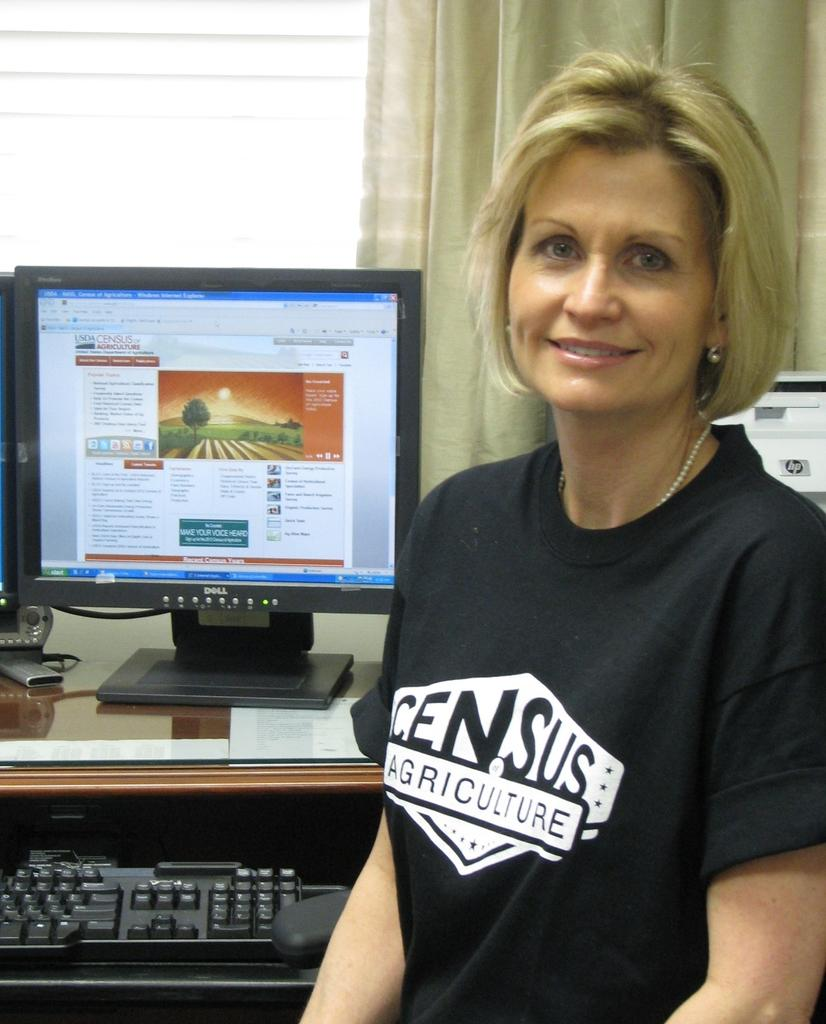<image>
Offer a succinct explanation of the picture presented. A picture of an office worker at their work station inside Census Agriculture 